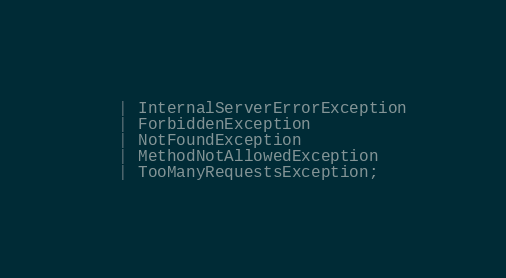Convert code to text. <code><loc_0><loc_0><loc_500><loc_500><_TypeScript_>  | InternalServerErrorException
  | ForbiddenException
  | NotFoundException
  | MethodNotAllowedException
  | TooManyRequestsException;
</code> 